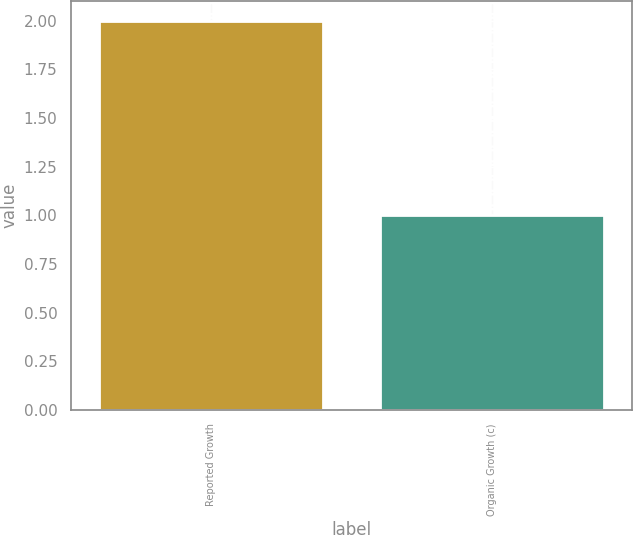Convert chart to OTSL. <chart><loc_0><loc_0><loc_500><loc_500><bar_chart><fcel>Reported Growth<fcel>Organic Growth (c)<nl><fcel>2<fcel>1<nl></chart> 